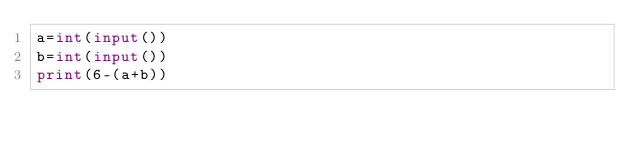Convert code to text. <code><loc_0><loc_0><loc_500><loc_500><_Python_>a=int(input())
b=int(input())
print(6-(a+b))</code> 